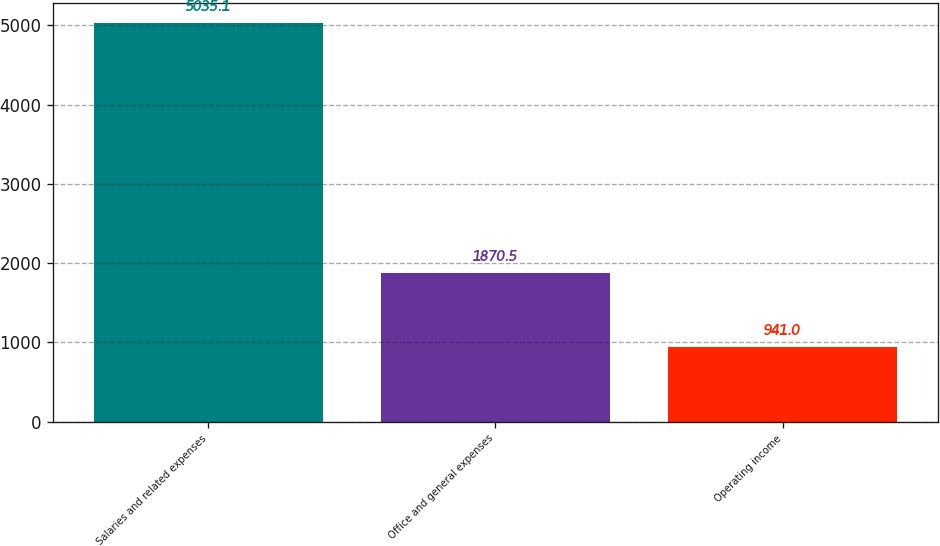<chart> <loc_0><loc_0><loc_500><loc_500><bar_chart><fcel>Salaries and related expenses<fcel>Office and general expenses<fcel>Operating income<nl><fcel>5035.1<fcel>1870.5<fcel>941<nl></chart> 